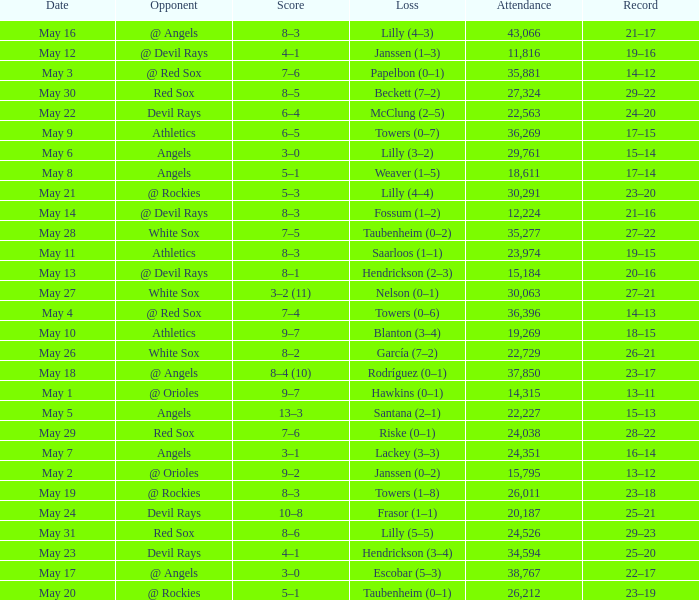What was the average attendance for games with a loss of papelbon (0–1)? 35881.0. 